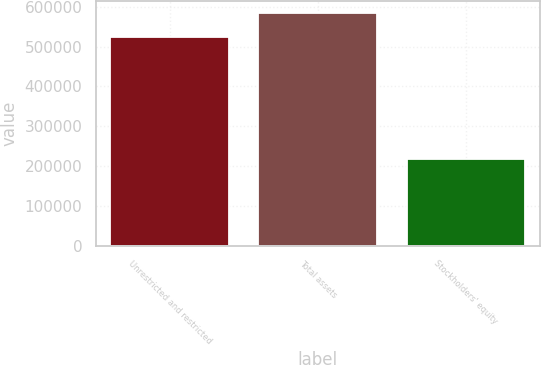Convert chart. <chart><loc_0><loc_0><loc_500><loc_500><bar_chart><fcel>Unrestricted and restricted<fcel>Total assets<fcel>Stockholders' equity<nl><fcel>522859<fcel>585090<fcel>216624<nl></chart> 